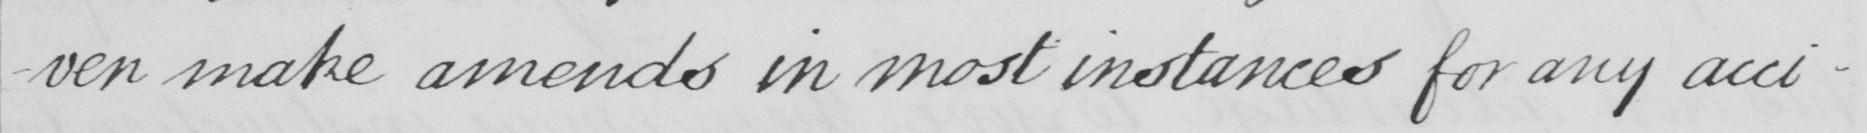Please transcribe the handwritten text in this image. -ven make amends in most instances for any acci- 